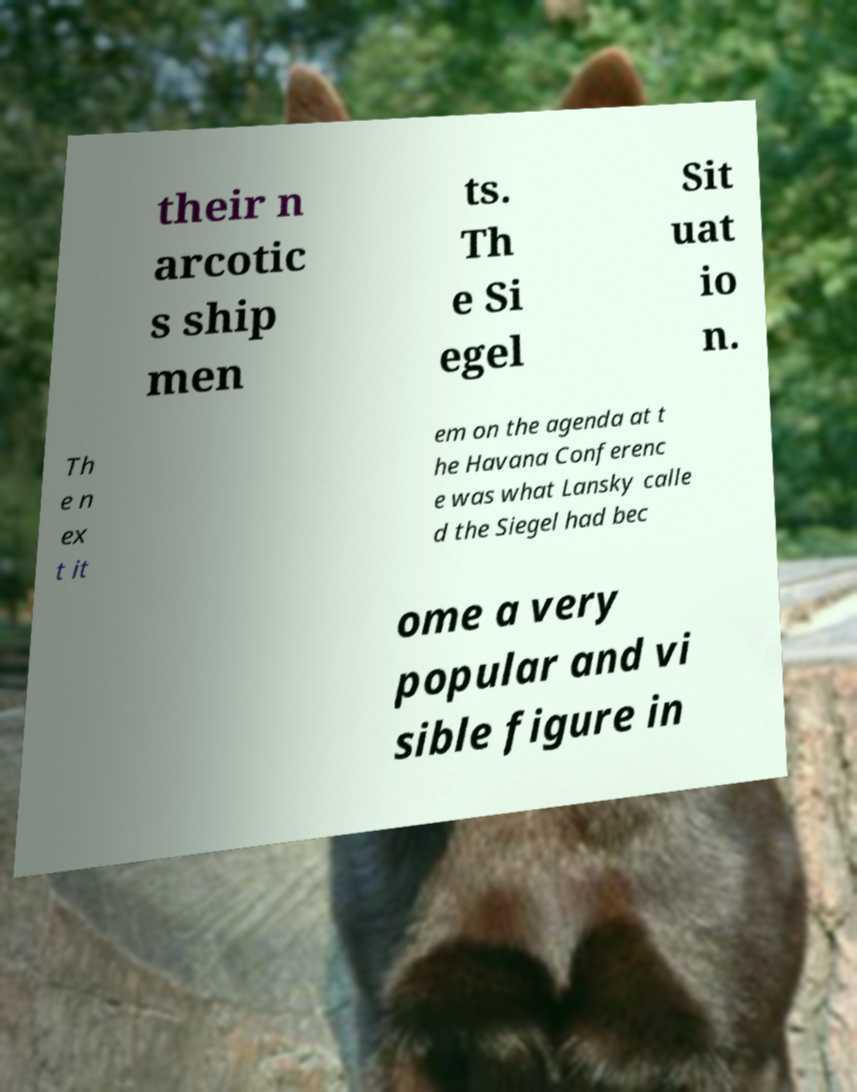For documentation purposes, I need the text within this image transcribed. Could you provide that? their n arcotic s ship men ts. Th e Si egel Sit uat io n. Th e n ex t it em on the agenda at t he Havana Conferenc e was what Lansky calle d the Siegel had bec ome a very popular and vi sible figure in 